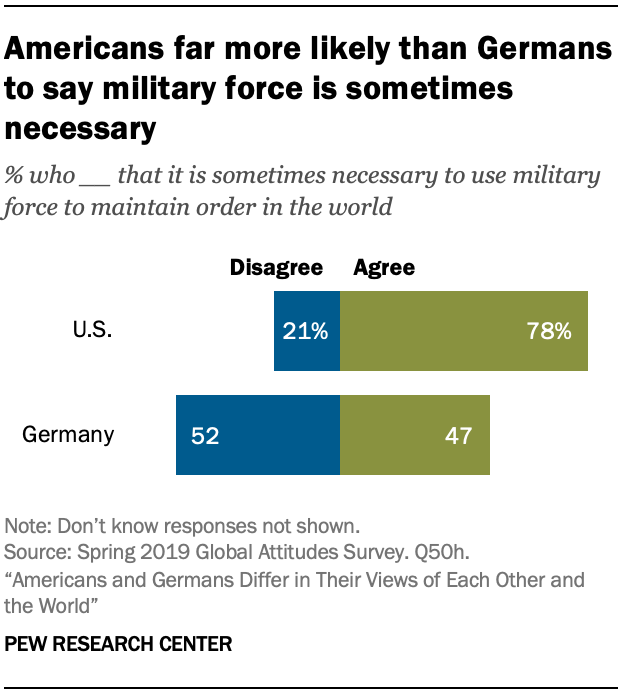Mention a couple of crucial points in this snapshot. The average of blue and green bars in Germany is 49.5. The percentage value of the green bar in the U.S. category is 78%. 